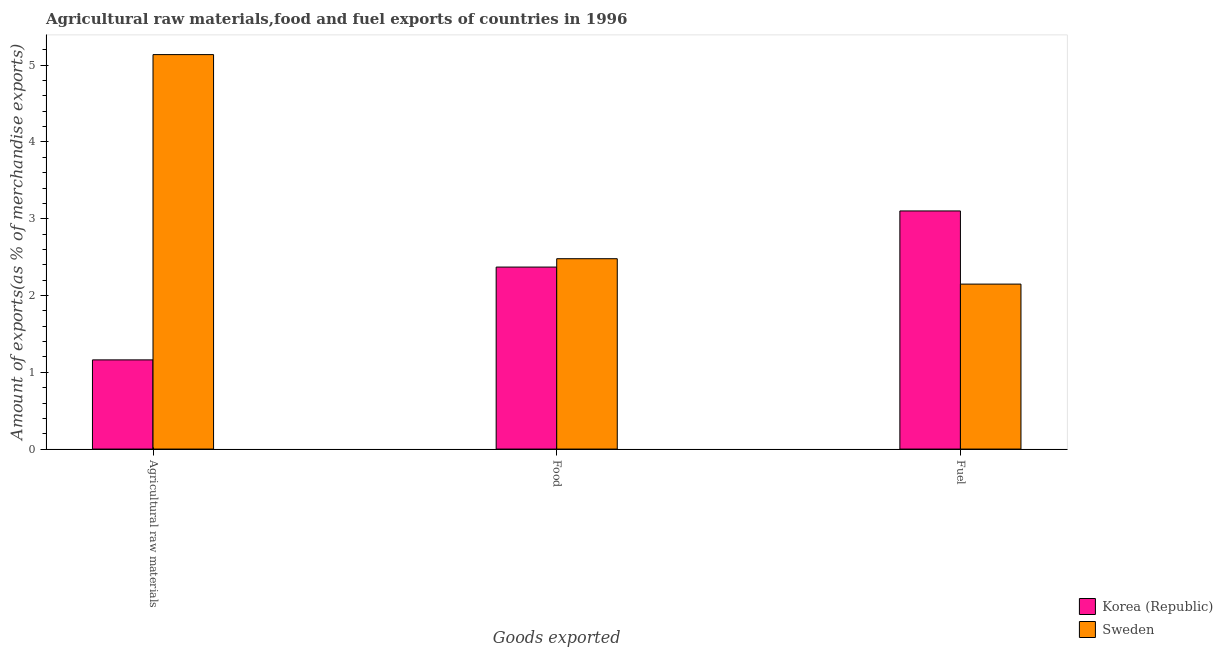How many groups of bars are there?
Give a very brief answer. 3. Are the number of bars per tick equal to the number of legend labels?
Keep it short and to the point. Yes. Are the number of bars on each tick of the X-axis equal?
Offer a very short reply. Yes. How many bars are there on the 3rd tick from the left?
Provide a short and direct response. 2. How many bars are there on the 1st tick from the right?
Your response must be concise. 2. What is the label of the 3rd group of bars from the left?
Provide a short and direct response. Fuel. What is the percentage of fuel exports in Korea (Republic)?
Provide a succinct answer. 3.1. Across all countries, what is the maximum percentage of fuel exports?
Provide a succinct answer. 3.1. Across all countries, what is the minimum percentage of food exports?
Offer a very short reply. 2.37. In which country was the percentage of fuel exports maximum?
Provide a succinct answer. Korea (Republic). What is the total percentage of raw materials exports in the graph?
Provide a short and direct response. 6.3. What is the difference between the percentage of food exports in Sweden and that in Korea (Republic)?
Give a very brief answer. 0.11. What is the difference between the percentage of food exports in Sweden and the percentage of raw materials exports in Korea (Republic)?
Make the answer very short. 1.32. What is the average percentage of fuel exports per country?
Make the answer very short. 2.63. What is the difference between the percentage of food exports and percentage of raw materials exports in Korea (Republic)?
Your response must be concise. 1.21. What is the ratio of the percentage of fuel exports in Korea (Republic) to that in Sweden?
Your answer should be compact. 1.44. Is the percentage of raw materials exports in Korea (Republic) less than that in Sweden?
Keep it short and to the point. Yes. Is the difference between the percentage of fuel exports in Korea (Republic) and Sweden greater than the difference between the percentage of raw materials exports in Korea (Republic) and Sweden?
Give a very brief answer. Yes. What is the difference between the highest and the second highest percentage of raw materials exports?
Your answer should be very brief. 3.98. What is the difference between the highest and the lowest percentage of food exports?
Ensure brevity in your answer.  0.11. What does the 1st bar from the left in Food represents?
Ensure brevity in your answer.  Korea (Republic). What does the 2nd bar from the right in Fuel represents?
Your response must be concise. Korea (Republic). How many countries are there in the graph?
Your response must be concise. 2. How many legend labels are there?
Provide a succinct answer. 2. What is the title of the graph?
Offer a very short reply. Agricultural raw materials,food and fuel exports of countries in 1996. Does "South Africa" appear as one of the legend labels in the graph?
Your answer should be compact. No. What is the label or title of the X-axis?
Your answer should be very brief. Goods exported. What is the label or title of the Y-axis?
Offer a terse response. Amount of exports(as % of merchandise exports). What is the Amount of exports(as % of merchandise exports) of Korea (Republic) in Agricultural raw materials?
Ensure brevity in your answer.  1.16. What is the Amount of exports(as % of merchandise exports) in Sweden in Agricultural raw materials?
Ensure brevity in your answer.  5.14. What is the Amount of exports(as % of merchandise exports) of Korea (Republic) in Food?
Offer a very short reply. 2.37. What is the Amount of exports(as % of merchandise exports) of Sweden in Food?
Make the answer very short. 2.48. What is the Amount of exports(as % of merchandise exports) of Korea (Republic) in Fuel?
Keep it short and to the point. 3.1. What is the Amount of exports(as % of merchandise exports) in Sweden in Fuel?
Give a very brief answer. 2.15. Across all Goods exported, what is the maximum Amount of exports(as % of merchandise exports) in Korea (Republic)?
Keep it short and to the point. 3.1. Across all Goods exported, what is the maximum Amount of exports(as % of merchandise exports) of Sweden?
Give a very brief answer. 5.14. Across all Goods exported, what is the minimum Amount of exports(as % of merchandise exports) of Korea (Republic)?
Make the answer very short. 1.16. Across all Goods exported, what is the minimum Amount of exports(as % of merchandise exports) of Sweden?
Make the answer very short. 2.15. What is the total Amount of exports(as % of merchandise exports) of Korea (Republic) in the graph?
Your answer should be very brief. 6.63. What is the total Amount of exports(as % of merchandise exports) in Sweden in the graph?
Your response must be concise. 9.77. What is the difference between the Amount of exports(as % of merchandise exports) in Korea (Republic) in Agricultural raw materials and that in Food?
Give a very brief answer. -1.21. What is the difference between the Amount of exports(as % of merchandise exports) in Sweden in Agricultural raw materials and that in Food?
Provide a short and direct response. 2.66. What is the difference between the Amount of exports(as % of merchandise exports) of Korea (Republic) in Agricultural raw materials and that in Fuel?
Your response must be concise. -1.94. What is the difference between the Amount of exports(as % of merchandise exports) in Sweden in Agricultural raw materials and that in Fuel?
Offer a terse response. 2.99. What is the difference between the Amount of exports(as % of merchandise exports) in Korea (Republic) in Food and that in Fuel?
Your response must be concise. -0.73. What is the difference between the Amount of exports(as % of merchandise exports) of Sweden in Food and that in Fuel?
Provide a succinct answer. 0.33. What is the difference between the Amount of exports(as % of merchandise exports) in Korea (Republic) in Agricultural raw materials and the Amount of exports(as % of merchandise exports) in Sweden in Food?
Offer a very short reply. -1.32. What is the difference between the Amount of exports(as % of merchandise exports) of Korea (Republic) in Agricultural raw materials and the Amount of exports(as % of merchandise exports) of Sweden in Fuel?
Provide a succinct answer. -0.99. What is the difference between the Amount of exports(as % of merchandise exports) in Korea (Republic) in Food and the Amount of exports(as % of merchandise exports) in Sweden in Fuel?
Make the answer very short. 0.22. What is the average Amount of exports(as % of merchandise exports) in Korea (Republic) per Goods exported?
Provide a succinct answer. 2.21. What is the average Amount of exports(as % of merchandise exports) of Sweden per Goods exported?
Your answer should be compact. 3.26. What is the difference between the Amount of exports(as % of merchandise exports) in Korea (Republic) and Amount of exports(as % of merchandise exports) in Sweden in Agricultural raw materials?
Give a very brief answer. -3.98. What is the difference between the Amount of exports(as % of merchandise exports) in Korea (Republic) and Amount of exports(as % of merchandise exports) in Sweden in Food?
Make the answer very short. -0.11. What is the difference between the Amount of exports(as % of merchandise exports) in Korea (Republic) and Amount of exports(as % of merchandise exports) in Sweden in Fuel?
Offer a very short reply. 0.95. What is the ratio of the Amount of exports(as % of merchandise exports) of Korea (Republic) in Agricultural raw materials to that in Food?
Offer a very short reply. 0.49. What is the ratio of the Amount of exports(as % of merchandise exports) in Sweden in Agricultural raw materials to that in Food?
Provide a short and direct response. 2.07. What is the ratio of the Amount of exports(as % of merchandise exports) of Korea (Republic) in Agricultural raw materials to that in Fuel?
Keep it short and to the point. 0.37. What is the ratio of the Amount of exports(as % of merchandise exports) of Sweden in Agricultural raw materials to that in Fuel?
Make the answer very short. 2.39. What is the ratio of the Amount of exports(as % of merchandise exports) of Korea (Republic) in Food to that in Fuel?
Provide a short and direct response. 0.76. What is the ratio of the Amount of exports(as % of merchandise exports) of Sweden in Food to that in Fuel?
Offer a terse response. 1.15. What is the difference between the highest and the second highest Amount of exports(as % of merchandise exports) in Korea (Republic)?
Your answer should be compact. 0.73. What is the difference between the highest and the second highest Amount of exports(as % of merchandise exports) of Sweden?
Keep it short and to the point. 2.66. What is the difference between the highest and the lowest Amount of exports(as % of merchandise exports) in Korea (Republic)?
Your answer should be very brief. 1.94. What is the difference between the highest and the lowest Amount of exports(as % of merchandise exports) in Sweden?
Keep it short and to the point. 2.99. 